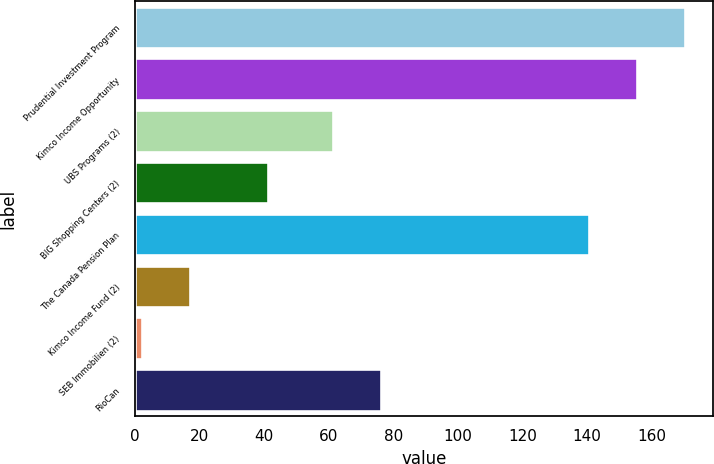Convert chart. <chart><loc_0><loc_0><loc_500><loc_500><bar_chart><fcel>Prudential Investment Program<fcel>Kimco Income Opportunity<fcel>UBS Programs (2)<fcel>BIG Shopping Centers (2)<fcel>The Canada Pension Plan<fcel>Kimco Income Fund (2)<fcel>SEB Immobilien (2)<fcel>RioCan<nl><fcel>170.56<fcel>155.58<fcel>61.3<fcel>41.2<fcel>140.6<fcel>17.08<fcel>2.1<fcel>76.28<nl></chart> 